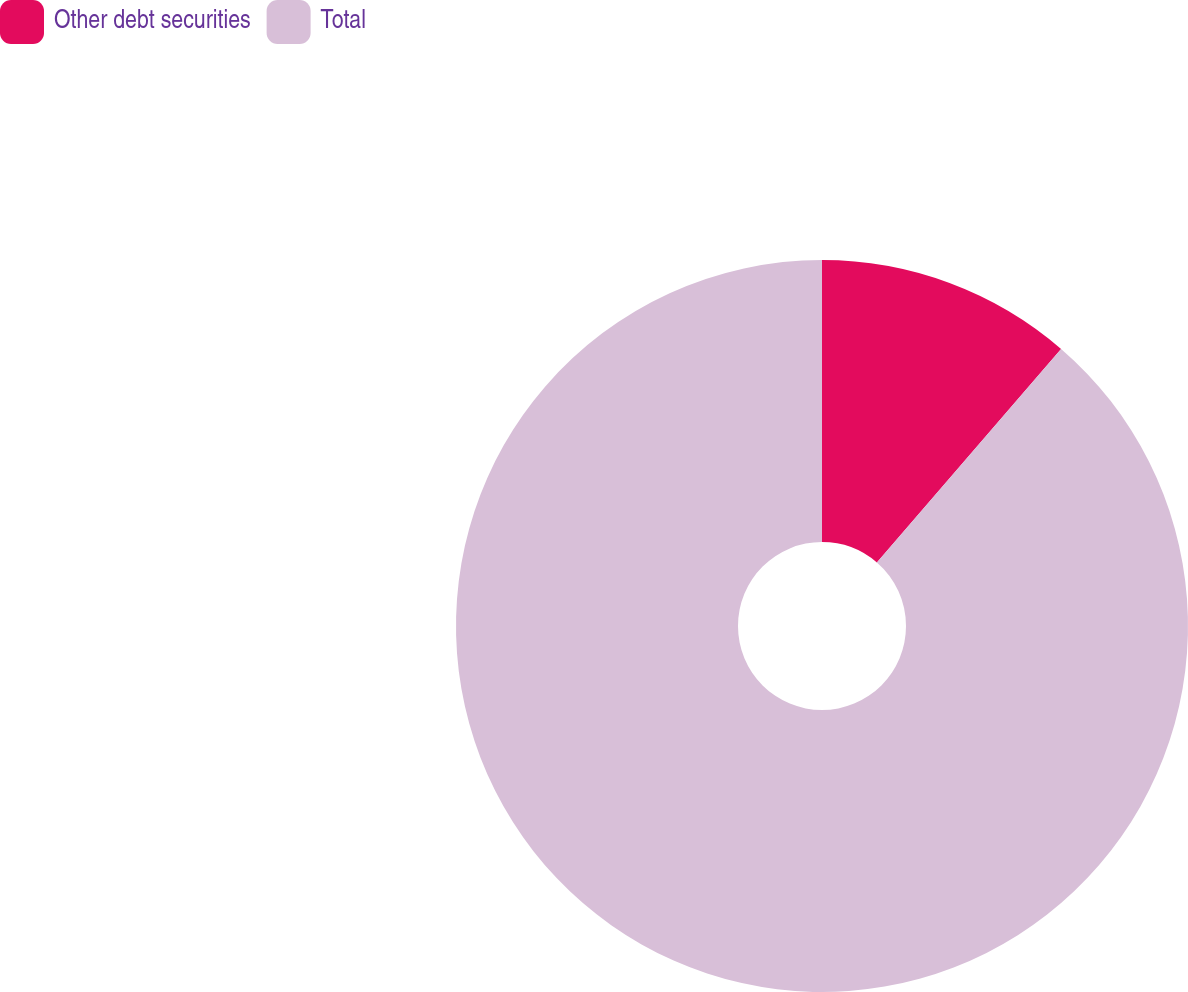<chart> <loc_0><loc_0><loc_500><loc_500><pie_chart><fcel>Other debt securities<fcel>Total<nl><fcel>11.33%<fcel>88.67%<nl></chart> 